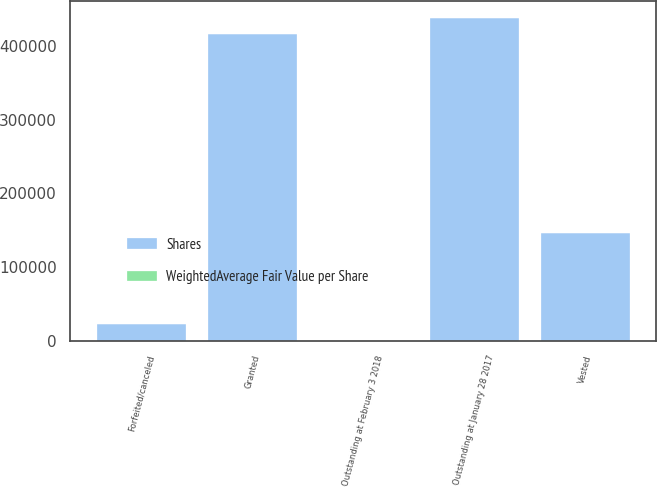Convert chart. <chart><loc_0><loc_0><loc_500><loc_500><stacked_bar_chart><ecel><fcel>Outstanding at January 28 2017<fcel>Granted<fcel>Vested<fcel>Forfeited/canceled<fcel>Outstanding at February 3 2018<nl><fcel>Shares<fcel>438000<fcel>416000<fcel>146000<fcel>23000<fcel>42.31<nl><fcel>WeightedAverage Fair Value per Share<fcel>28.98<fcel>42.31<fcel>28.98<fcel>29.66<fcel>37.04<nl></chart> 